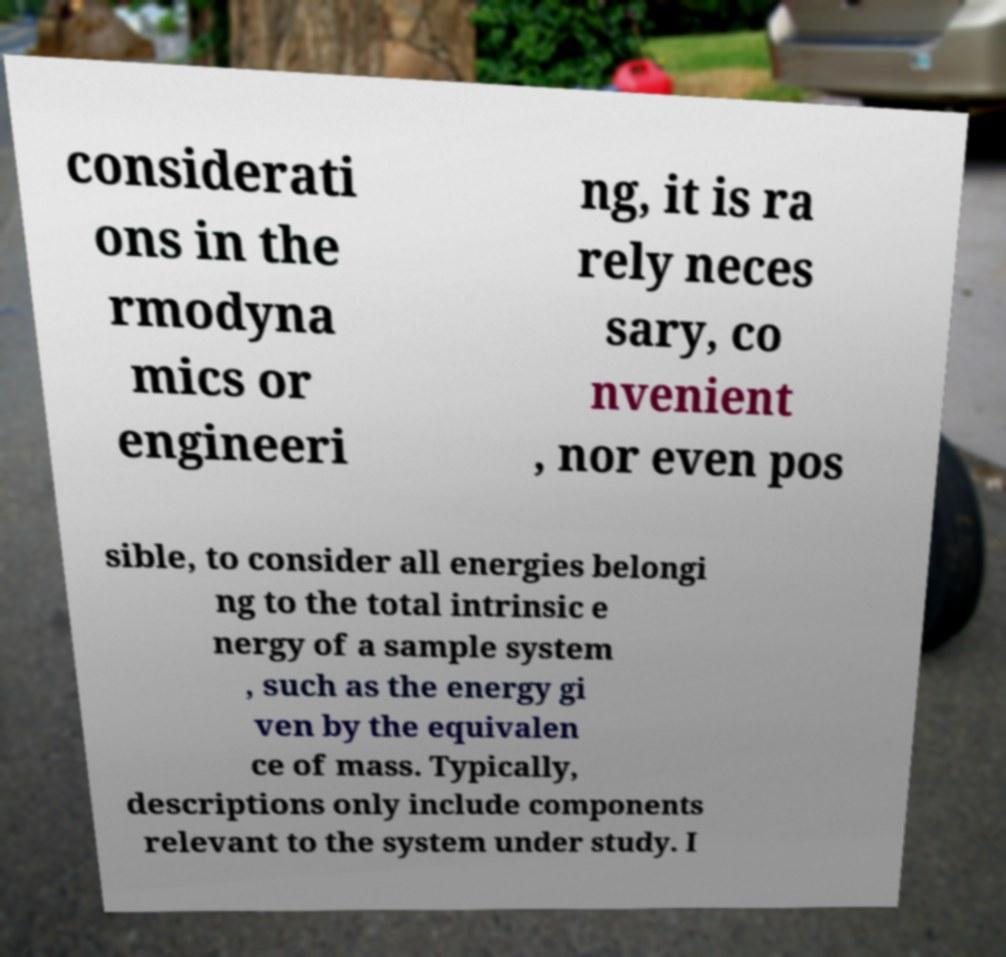Please identify and transcribe the text found in this image. considerati ons in the rmodyna mics or engineeri ng, it is ra rely neces sary, co nvenient , nor even pos sible, to consider all energies belongi ng to the total intrinsic e nergy of a sample system , such as the energy gi ven by the equivalen ce of mass. Typically, descriptions only include components relevant to the system under study. I 